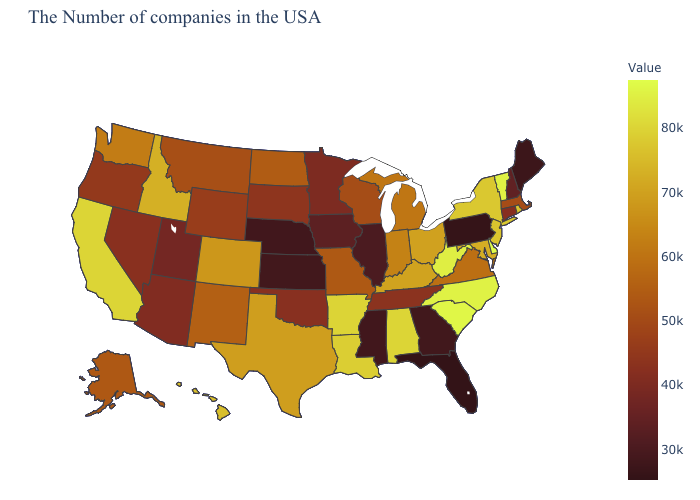Does West Virginia have a lower value than Hawaii?
Quick response, please. No. Does Iowa have a lower value than North Dakota?
Be succinct. Yes. Does the map have missing data?
Be succinct. No. Which states have the lowest value in the USA?
Keep it brief. Florida. Does Vermont have the lowest value in the Northeast?
Concise answer only. No. 